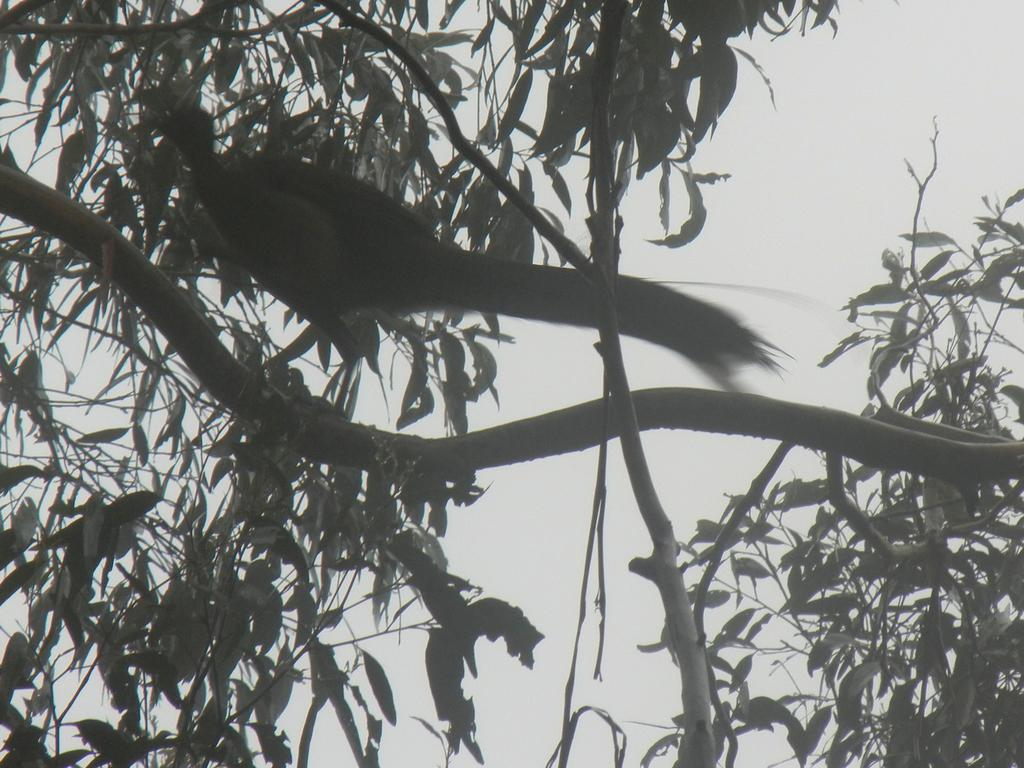What type of animal can be seen in the image? There is a bird in the image. Where is the bird located in the image? The bird is sitting on a branch. What is the branch a part of? The branch is part of a tree. What can be seen in the background of the image? Leaves are present in the background of the image. What type of floor can be seen in the image? There is no floor present in the image; it features a bird sitting on a branch of a tree. 